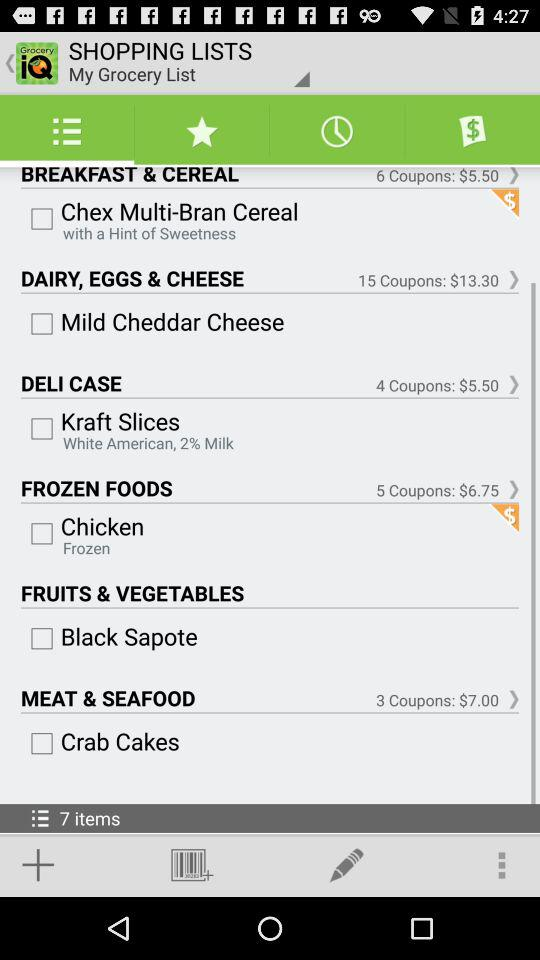How many coupons are there in the Deli Case? There are 4 coupons. 